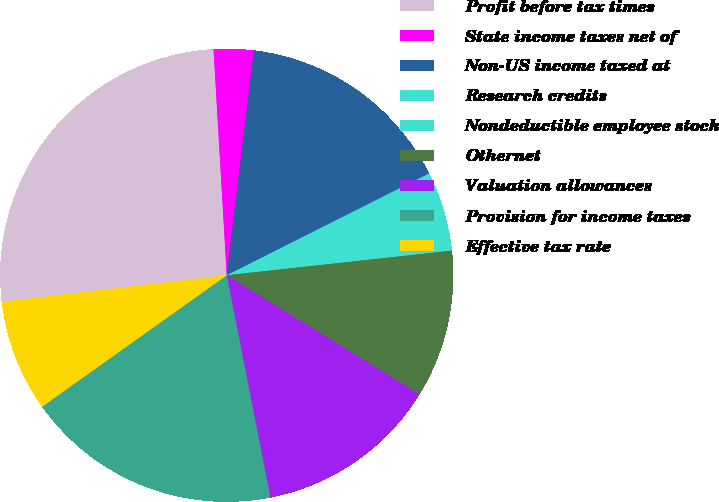Convert chart. <chart><loc_0><loc_0><loc_500><loc_500><pie_chart><fcel>Profit before tax times<fcel>State income taxes net of<fcel>Non-US income taxed at<fcel>Research credits<fcel>Nondeductible employee stock<fcel>Othernet<fcel>Valuation allowances<fcel>Provision for income taxes<fcel>Effective tax rate<nl><fcel>25.94%<fcel>2.84%<fcel>15.67%<fcel>5.41%<fcel>0.27%<fcel>10.54%<fcel>13.11%<fcel>18.24%<fcel>7.97%<nl></chart> 